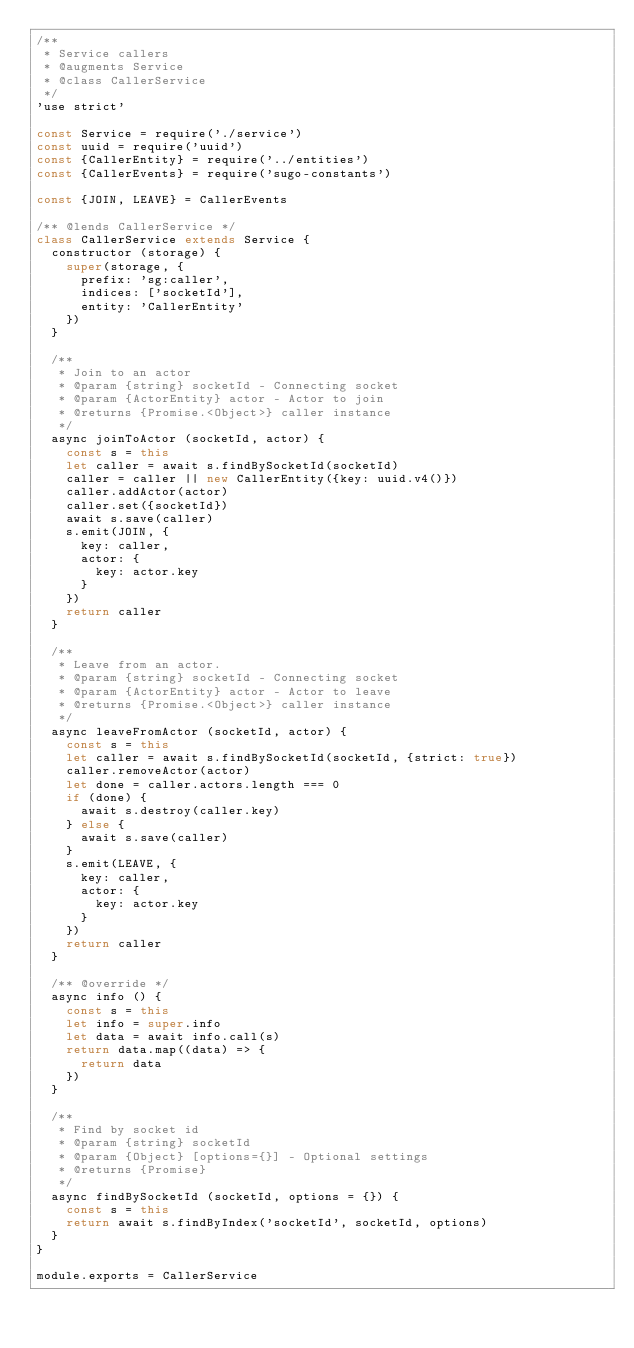<code> <loc_0><loc_0><loc_500><loc_500><_JavaScript_>/**
 * Service callers
 * @augments Service
 * @class CallerService
 */
'use strict'

const Service = require('./service')
const uuid = require('uuid')
const {CallerEntity} = require('../entities')
const {CallerEvents} = require('sugo-constants')

const {JOIN, LEAVE} = CallerEvents

/** @lends CallerService */
class CallerService extends Service {
  constructor (storage) {
    super(storage, {
      prefix: 'sg:caller',
      indices: ['socketId'],
      entity: 'CallerEntity'
    })
  }

  /**
   * Join to an actor
   * @param {string} socketId - Connecting socket
   * @param {ActorEntity} actor - Actor to join
   * @returns {Promise.<Object>} caller instance
   */
  async joinToActor (socketId, actor) {
    const s = this
    let caller = await s.findBySocketId(socketId)
    caller = caller || new CallerEntity({key: uuid.v4()})
    caller.addActor(actor)
    caller.set({socketId})
    await s.save(caller)
    s.emit(JOIN, {
      key: caller,
      actor: {
        key: actor.key
      }
    })
    return caller
  }

  /**
   * Leave from an actor.
   * @param {string} socketId - Connecting socket
   * @param {ActorEntity} actor - Actor to leave
   * @returns {Promise.<Object>} caller instance
   */
  async leaveFromActor (socketId, actor) {
    const s = this
    let caller = await s.findBySocketId(socketId, {strict: true})
    caller.removeActor(actor)
    let done = caller.actors.length === 0
    if (done) {
      await s.destroy(caller.key)
    } else {
      await s.save(caller)
    }
    s.emit(LEAVE, {
      key: caller,
      actor: {
        key: actor.key
      }
    })
    return caller
  }

  /** @override */
  async info () {
    const s = this
    let info = super.info
    let data = await info.call(s)
    return data.map((data) => {
      return data
    })
  }

  /**
   * Find by socket id
   * @param {string} socketId
   * @param {Object} [options={}] - Optional settings
   * @returns {Promise}
   */
  async findBySocketId (socketId, options = {}) {
    const s = this
    return await s.findByIndex('socketId', socketId, options)
  }
}

module.exports = CallerService
</code> 